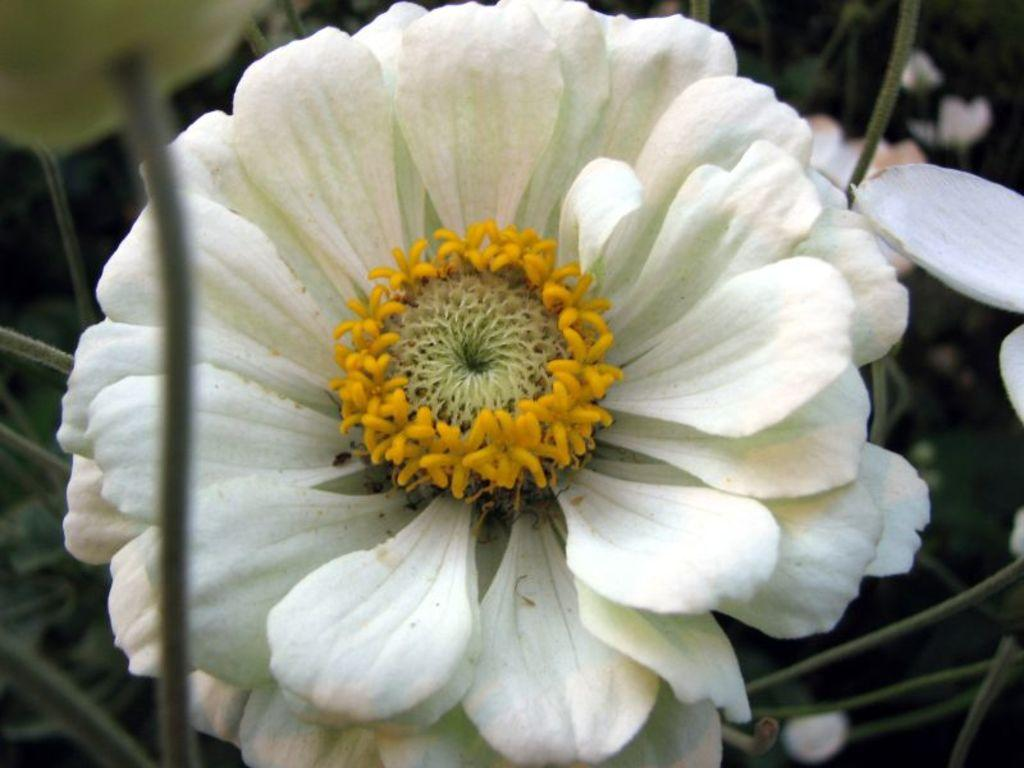What type of flower can be seen in the image? There is a white flower in the image. Where is the flower located in the image? There is a flower towards the right side of the image. Can you describe the appearance of the flower in the image? There is a flower that appears to be truncated towards the top of the image. What is the health condition of the person in the image? There is no person present in the image, only a white flower. 